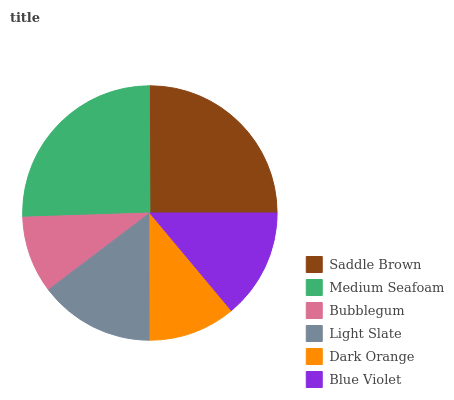Is Bubblegum the minimum?
Answer yes or no. Yes. Is Medium Seafoam the maximum?
Answer yes or no. Yes. Is Medium Seafoam the minimum?
Answer yes or no. No. Is Bubblegum the maximum?
Answer yes or no. No. Is Medium Seafoam greater than Bubblegum?
Answer yes or no. Yes. Is Bubblegum less than Medium Seafoam?
Answer yes or no. Yes. Is Bubblegum greater than Medium Seafoam?
Answer yes or no. No. Is Medium Seafoam less than Bubblegum?
Answer yes or no. No. Is Light Slate the high median?
Answer yes or no. Yes. Is Blue Violet the low median?
Answer yes or no. Yes. Is Medium Seafoam the high median?
Answer yes or no. No. Is Bubblegum the low median?
Answer yes or no. No. 